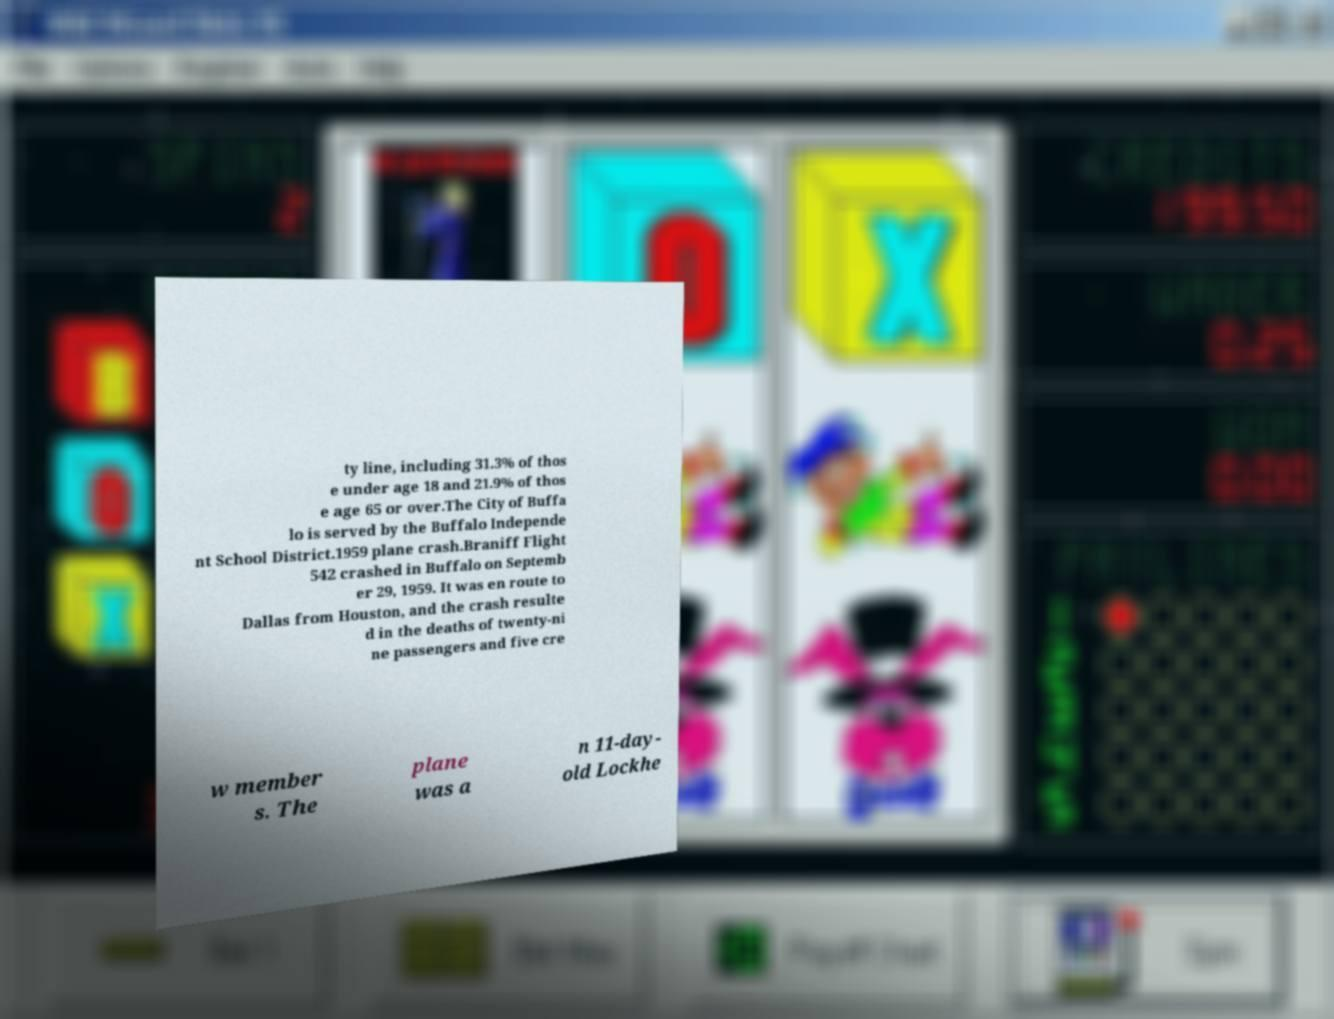Can you accurately transcribe the text from the provided image for me? ty line, including 31.3% of thos e under age 18 and 21.9% of thos e age 65 or over.The City of Buffa lo is served by the Buffalo Independe nt School District.1959 plane crash.Braniff Flight 542 crashed in Buffalo on Septemb er 29, 1959. It was en route to Dallas from Houston, and the crash resulte d in the deaths of twenty-ni ne passengers and five cre w member s. The plane was a n 11-day- old Lockhe 